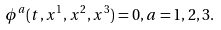Convert formula to latex. <formula><loc_0><loc_0><loc_500><loc_500>\phi ^ { a } ( t , x ^ { 1 } , x ^ { 2 } , x ^ { 3 } ) = 0 , a = 1 , 2 , 3 .</formula> 